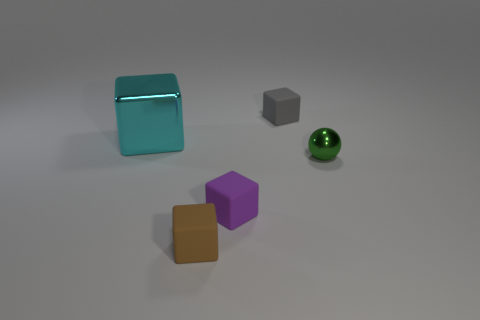Subtract all tiny gray rubber cubes. How many cubes are left? 3 Subtract all brown cubes. How many cubes are left? 3 Subtract 1 blocks. How many blocks are left? 3 Add 1 cyan cubes. How many objects exist? 6 Subtract all blue blocks. Subtract all cyan spheres. How many blocks are left? 4 Subtract all balls. How many objects are left? 4 Subtract all small green balls. Subtract all green balls. How many objects are left? 3 Add 1 large cyan metallic objects. How many large cyan metallic objects are left? 2 Add 3 purple matte spheres. How many purple matte spheres exist? 3 Subtract 0 blue cylinders. How many objects are left? 5 